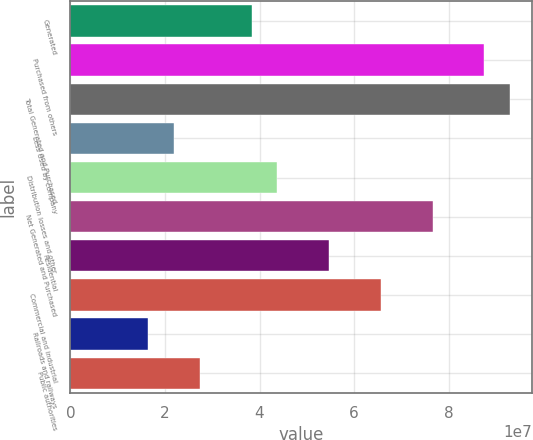<chart> <loc_0><loc_0><loc_500><loc_500><bar_chart><fcel>Generated<fcel>Purchased from others<fcel>Total Generated and Purchased<fcel>Less Used by company<fcel>Distribution losses and other<fcel>Net Generated and Purchased<fcel>Residential<fcel>Commercial and industrial<fcel>Railroads and railways<fcel>Public authorities<nl><fcel>3.83192e+07<fcel>8.75867e+07<fcel>9.30609e+07<fcel>2.18967e+07<fcel>4.37934e+07<fcel>7.66384e+07<fcel>5.47417e+07<fcel>6.569e+07<fcel>1.64225e+07<fcel>2.73709e+07<nl></chart> 